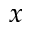Convert formula to latex. <formula><loc_0><loc_0><loc_500><loc_500>x</formula> 